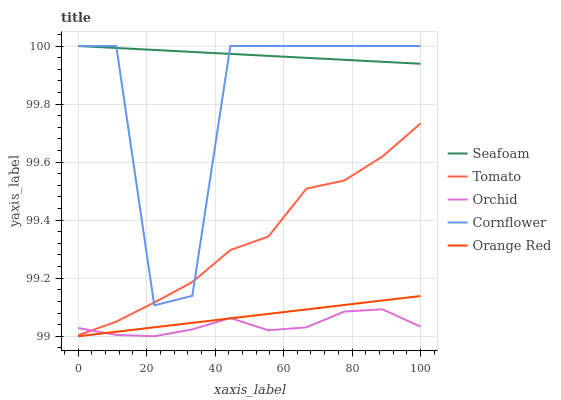Does Orchid have the minimum area under the curve?
Answer yes or no. Yes. Does Seafoam have the maximum area under the curve?
Answer yes or no. Yes. Does Cornflower have the minimum area under the curve?
Answer yes or no. No. Does Cornflower have the maximum area under the curve?
Answer yes or no. No. Is Orange Red the smoothest?
Answer yes or no. Yes. Is Cornflower the roughest?
Answer yes or no. Yes. Is Seafoam the smoothest?
Answer yes or no. No. Is Seafoam the roughest?
Answer yes or no. No. Does Cornflower have the lowest value?
Answer yes or no. No. Does Orange Red have the highest value?
Answer yes or no. No. Is Orchid less than Cornflower?
Answer yes or no. Yes. Is Seafoam greater than Orchid?
Answer yes or no. Yes. Does Orchid intersect Cornflower?
Answer yes or no. No. 